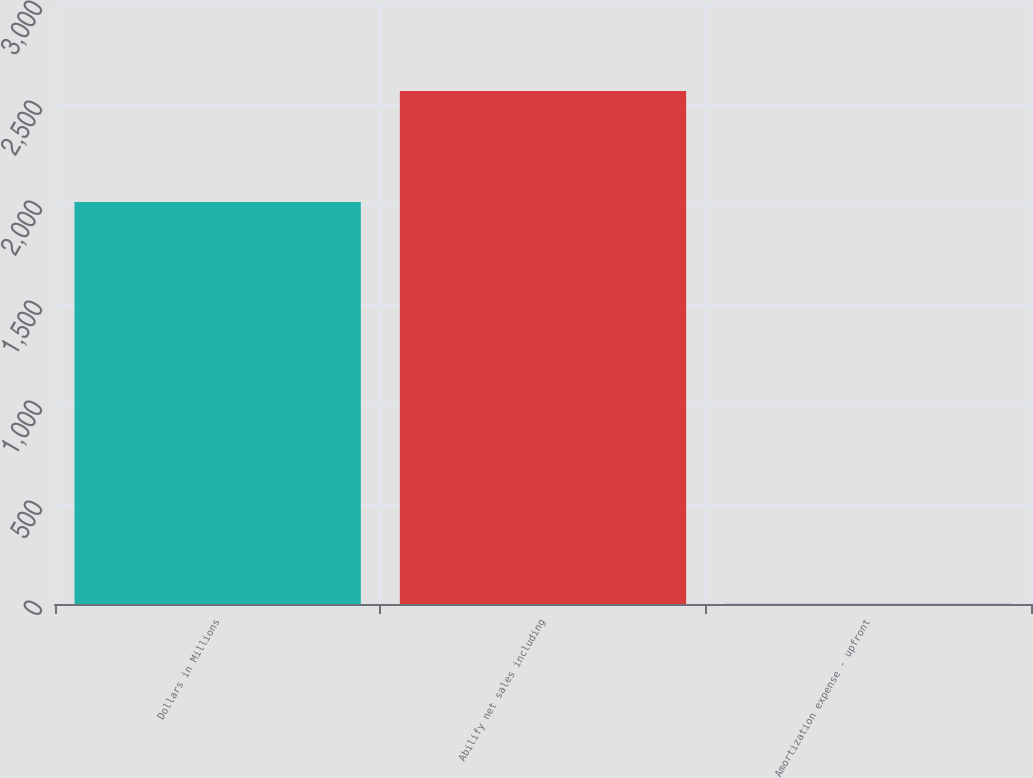Convert chart. <chart><loc_0><loc_0><loc_500><loc_500><bar_chart><fcel>Dollars in Millions<fcel>Abilify net sales including<fcel>Amortization expense - upfront<nl><fcel>2010<fcel>2565<fcel>6<nl></chart> 